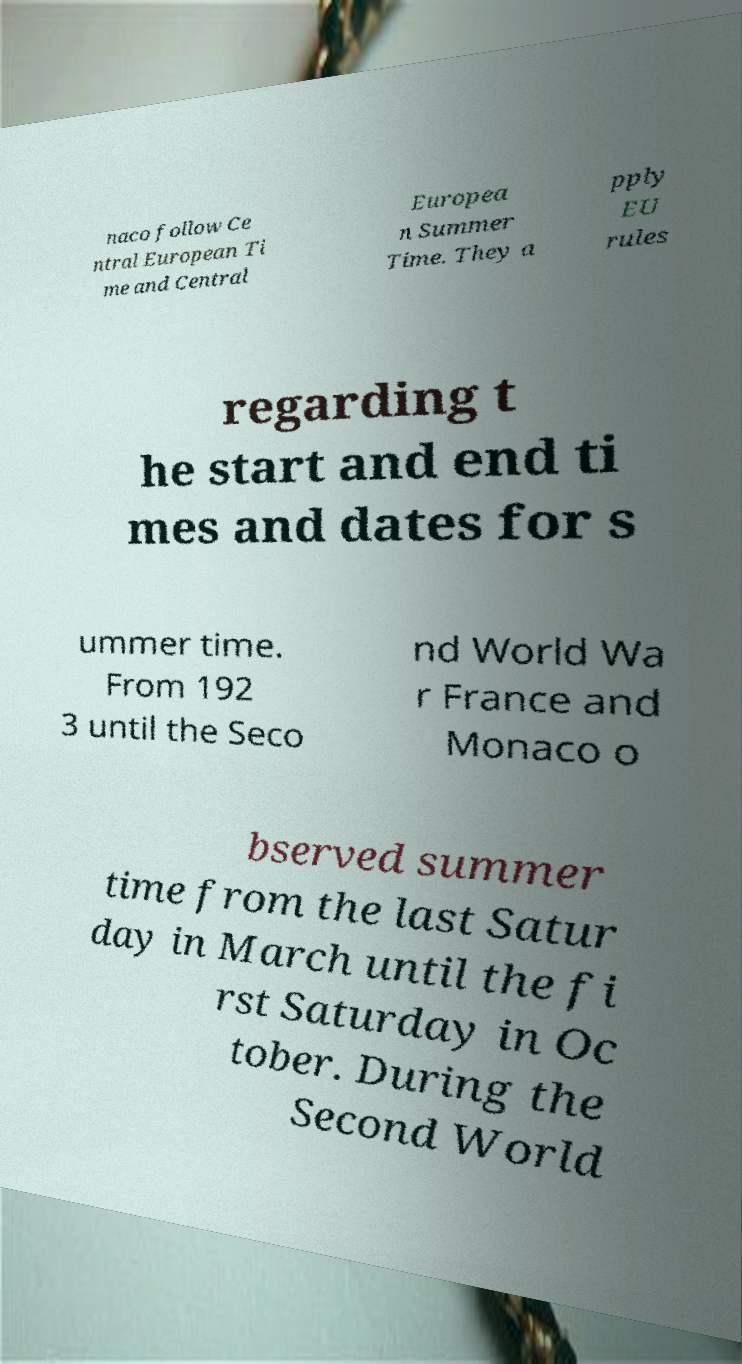What messages or text are displayed in this image? I need them in a readable, typed format. naco follow Ce ntral European Ti me and Central Europea n Summer Time. They a pply EU rules regarding t he start and end ti mes and dates for s ummer time. From 192 3 until the Seco nd World Wa r France and Monaco o bserved summer time from the last Satur day in March until the fi rst Saturday in Oc tober. During the Second World 